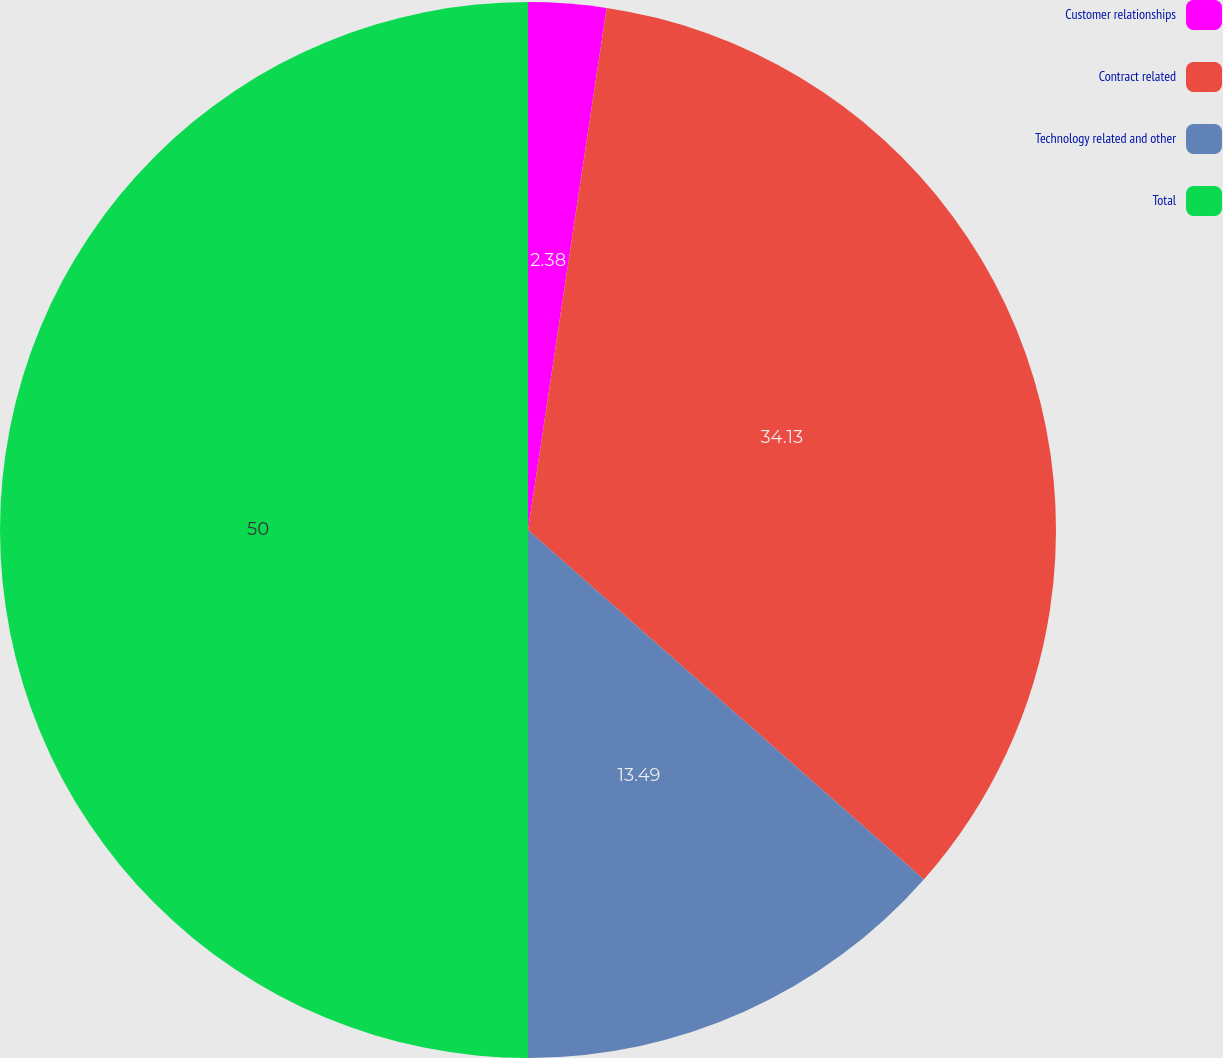Convert chart to OTSL. <chart><loc_0><loc_0><loc_500><loc_500><pie_chart><fcel>Customer relationships<fcel>Contract related<fcel>Technology related and other<fcel>Total<nl><fcel>2.38%<fcel>34.13%<fcel>13.49%<fcel>50.0%<nl></chart> 